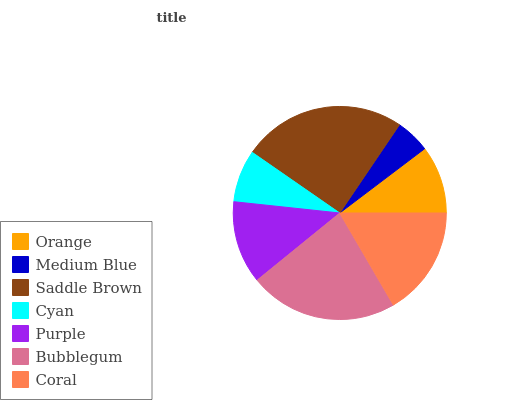Is Medium Blue the minimum?
Answer yes or no. Yes. Is Saddle Brown the maximum?
Answer yes or no. Yes. Is Saddle Brown the minimum?
Answer yes or no. No. Is Medium Blue the maximum?
Answer yes or no. No. Is Saddle Brown greater than Medium Blue?
Answer yes or no. Yes. Is Medium Blue less than Saddle Brown?
Answer yes or no. Yes. Is Medium Blue greater than Saddle Brown?
Answer yes or no. No. Is Saddle Brown less than Medium Blue?
Answer yes or no. No. Is Purple the high median?
Answer yes or no. Yes. Is Purple the low median?
Answer yes or no. Yes. Is Medium Blue the high median?
Answer yes or no. No. Is Cyan the low median?
Answer yes or no. No. 